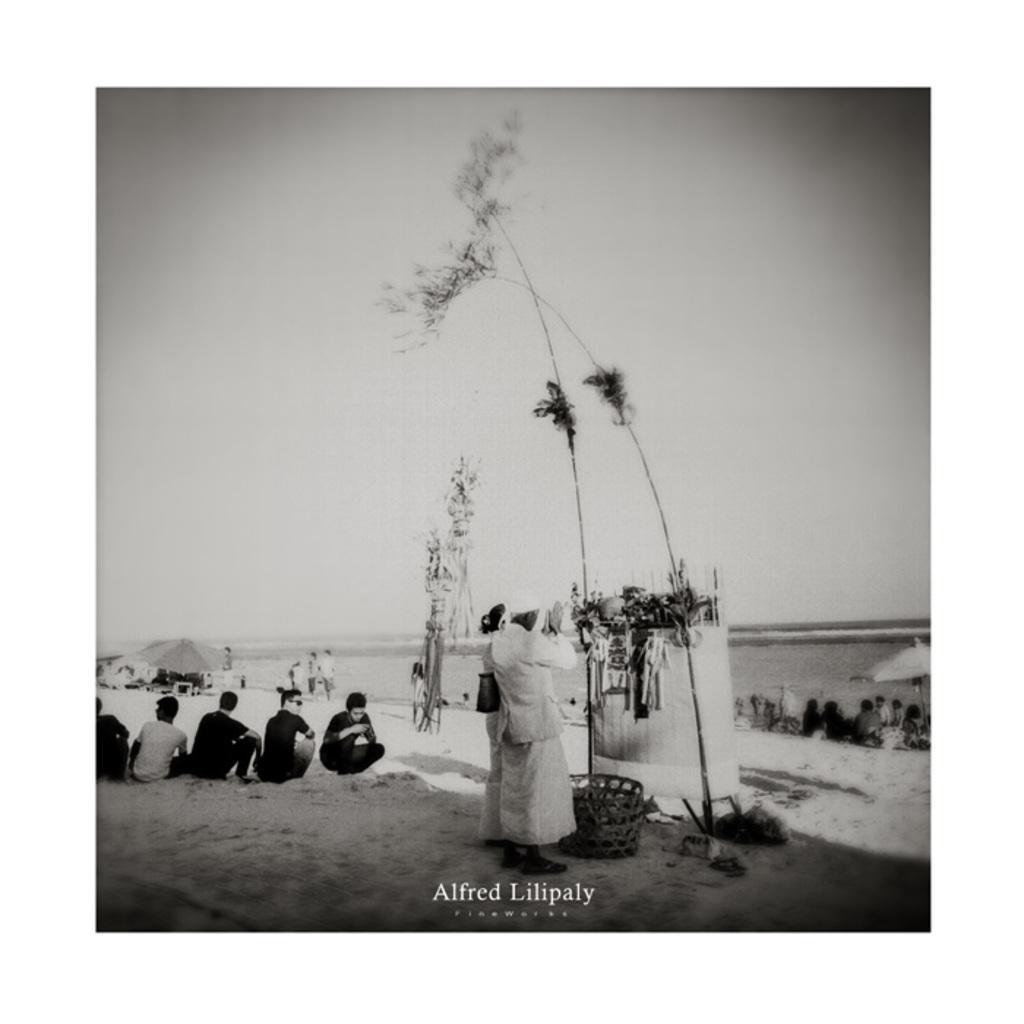How would you summarize this image in a sentence or two? This is a black and white image. Here I can see few plants. In front of these I can see two persons are standing and praying to it. On the right and left side of the image I can see few people are sitting on the ground. It is looking like a beach. In the background, I can see two umbrellas, under this few people are sitting. On the top of the image I can see the sky. At the bottom of this image I can see some text. 